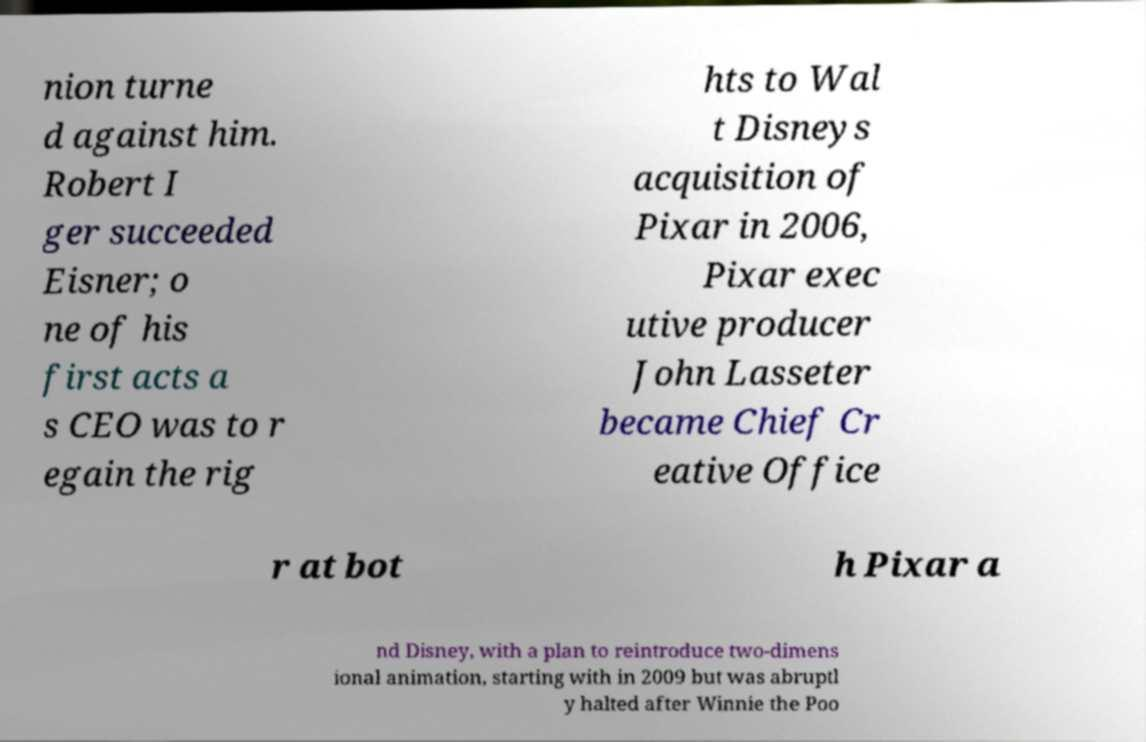Please identify and transcribe the text found in this image. nion turne d against him. Robert I ger succeeded Eisner; o ne of his first acts a s CEO was to r egain the rig hts to Wal t Disneys acquisition of Pixar in 2006, Pixar exec utive producer John Lasseter became Chief Cr eative Office r at bot h Pixar a nd Disney, with a plan to reintroduce two-dimens ional animation, starting with in 2009 but was abruptl y halted after Winnie the Poo 